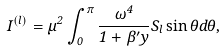<formula> <loc_0><loc_0><loc_500><loc_500>I ^ { \left ( l \right ) } = \mu ^ { 2 } \int _ { 0 } ^ { \pi } \frac { \omega ^ { 4 } } { 1 + \beta ^ { \prime } y } S _ { l } \sin \theta d \theta ,</formula> 